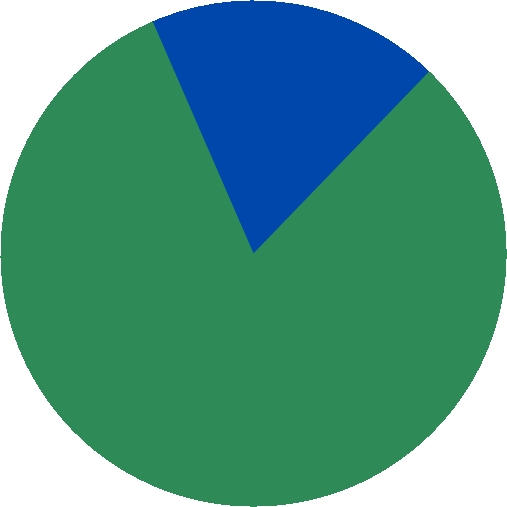Convert chart to OTSL. <chart><loc_0><loc_0><loc_500><loc_500><pie_chart><fcel>Non-US<fcel>Total<nl><fcel>18.75%<fcel>81.25%<nl></chart> 